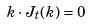<formula> <loc_0><loc_0><loc_500><loc_500>k \cdot J _ { t } ( k ) = 0</formula> 